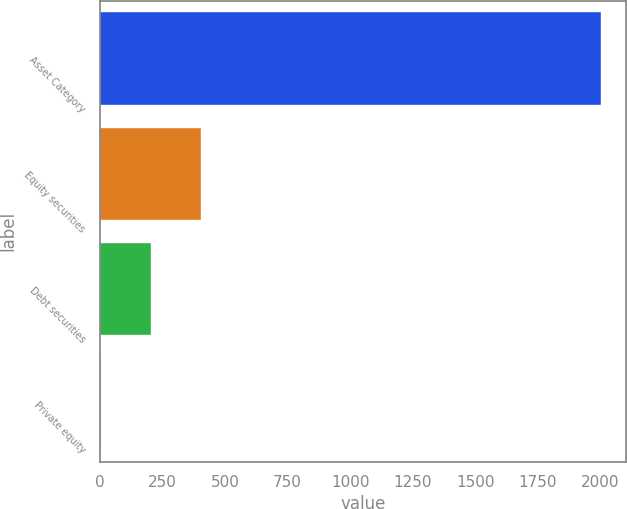<chart> <loc_0><loc_0><loc_500><loc_500><bar_chart><fcel>Asset Category<fcel>Equity securities<fcel>Debt securities<fcel>Private equity<nl><fcel>2003<fcel>403<fcel>203<fcel>3<nl></chart> 